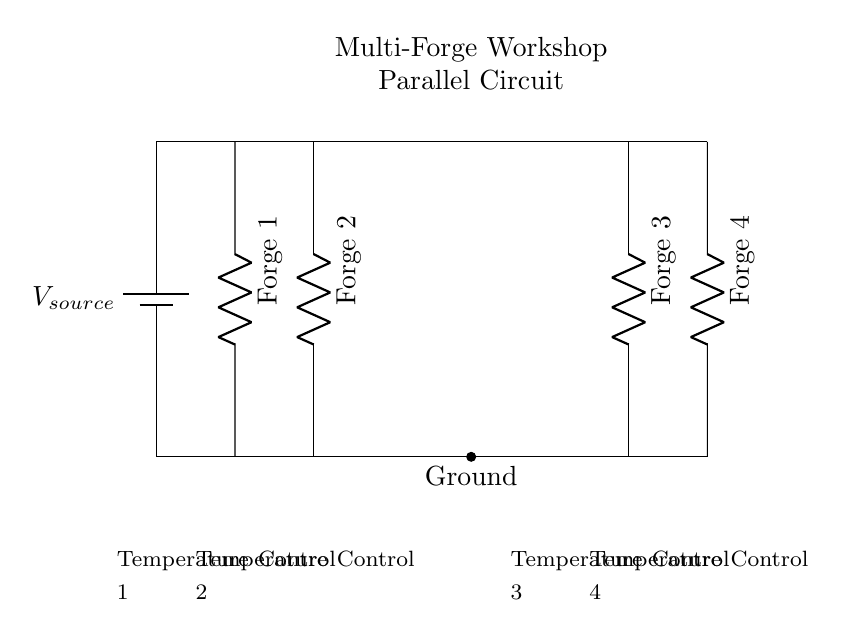What type of circuit is this? This is a parallel circuit, as evidenced by the multiple independent branches that connect to a common voltage source. Each forge is wired separately, allowing for independent operation.
Answer: Parallel How many forges are connected? There are four forges connected, indicated by the four resistors labeled Forge 1, Forge 2, Forge 3, and Forge 4 in the circuit diagram.
Answer: Four What does each forge control? Each forge controls its temperature independently, as indicated by the presence of separate temperature controls for each forge in the circuit.
Answer: Temperature What happens if one forge malfunctions? If one forge malfunctions, the others will remain operational because the components are wired in parallel, allowing each path to function independently regardless of the status of the others.
Answer: Remains operational What is the function of the battery? The battery serves as the voltage source, providing the necessary electrical energy to power all the forges connected in the parallel circuit.
Answer: Voltage source How would the current behave in this circuit? The total current is divided among the branches, meaning each forge receives current independently based on its resistance, which leads to variations in the current across each branch.
Answer: Divided among branches 